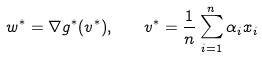<formula> <loc_0><loc_0><loc_500><loc_500>w ^ { * } = \nabla g ^ { * } ( v ^ { * } ) , \quad v ^ { * } = \frac { 1 } { n } \sum _ { i = 1 } ^ { n } \alpha _ { i } x _ { i }</formula> 